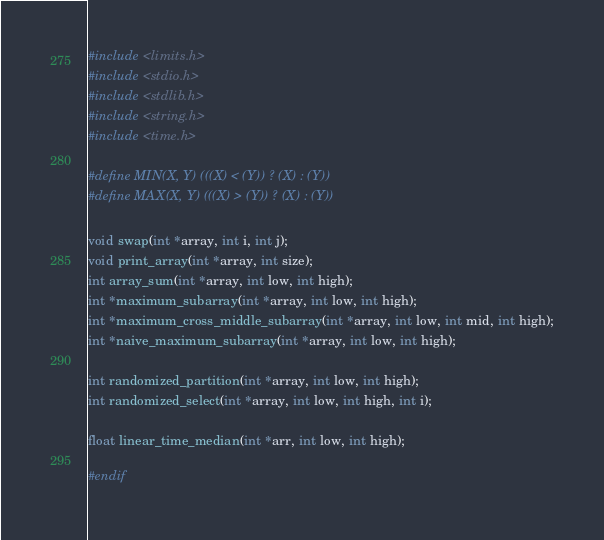<code> <loc_0><loc_0><loc_500><loc_500><_C_>
#include <limits.h>
#include <stdio.h>
#include <stdlib.h>
#include <string.h>
#include <time.h>

#define MIN(X, Y) (((X) < (Y)) ? (X) : (Y))
#define MAX(X, Y) (((X) > (Y)) ? (X) : (Y))

void swap(int *array, int i, int j);
void print_array(int *array, int size);
int array_sum(int *array, int low, int high);
int *maximum_subarray(int *array, int low, int high);
int *maximum_cross_middle_subarray(int *array, int low, int mid, int high);
int *naive_maximum_subarray(int *array, int low, int high);

int randomized_partition(int *array, int low, int high);
int randomized_select(int *array, int low, int high, int i);

float linear_time_median(int *arr, int low, int high);

#endif</code> 